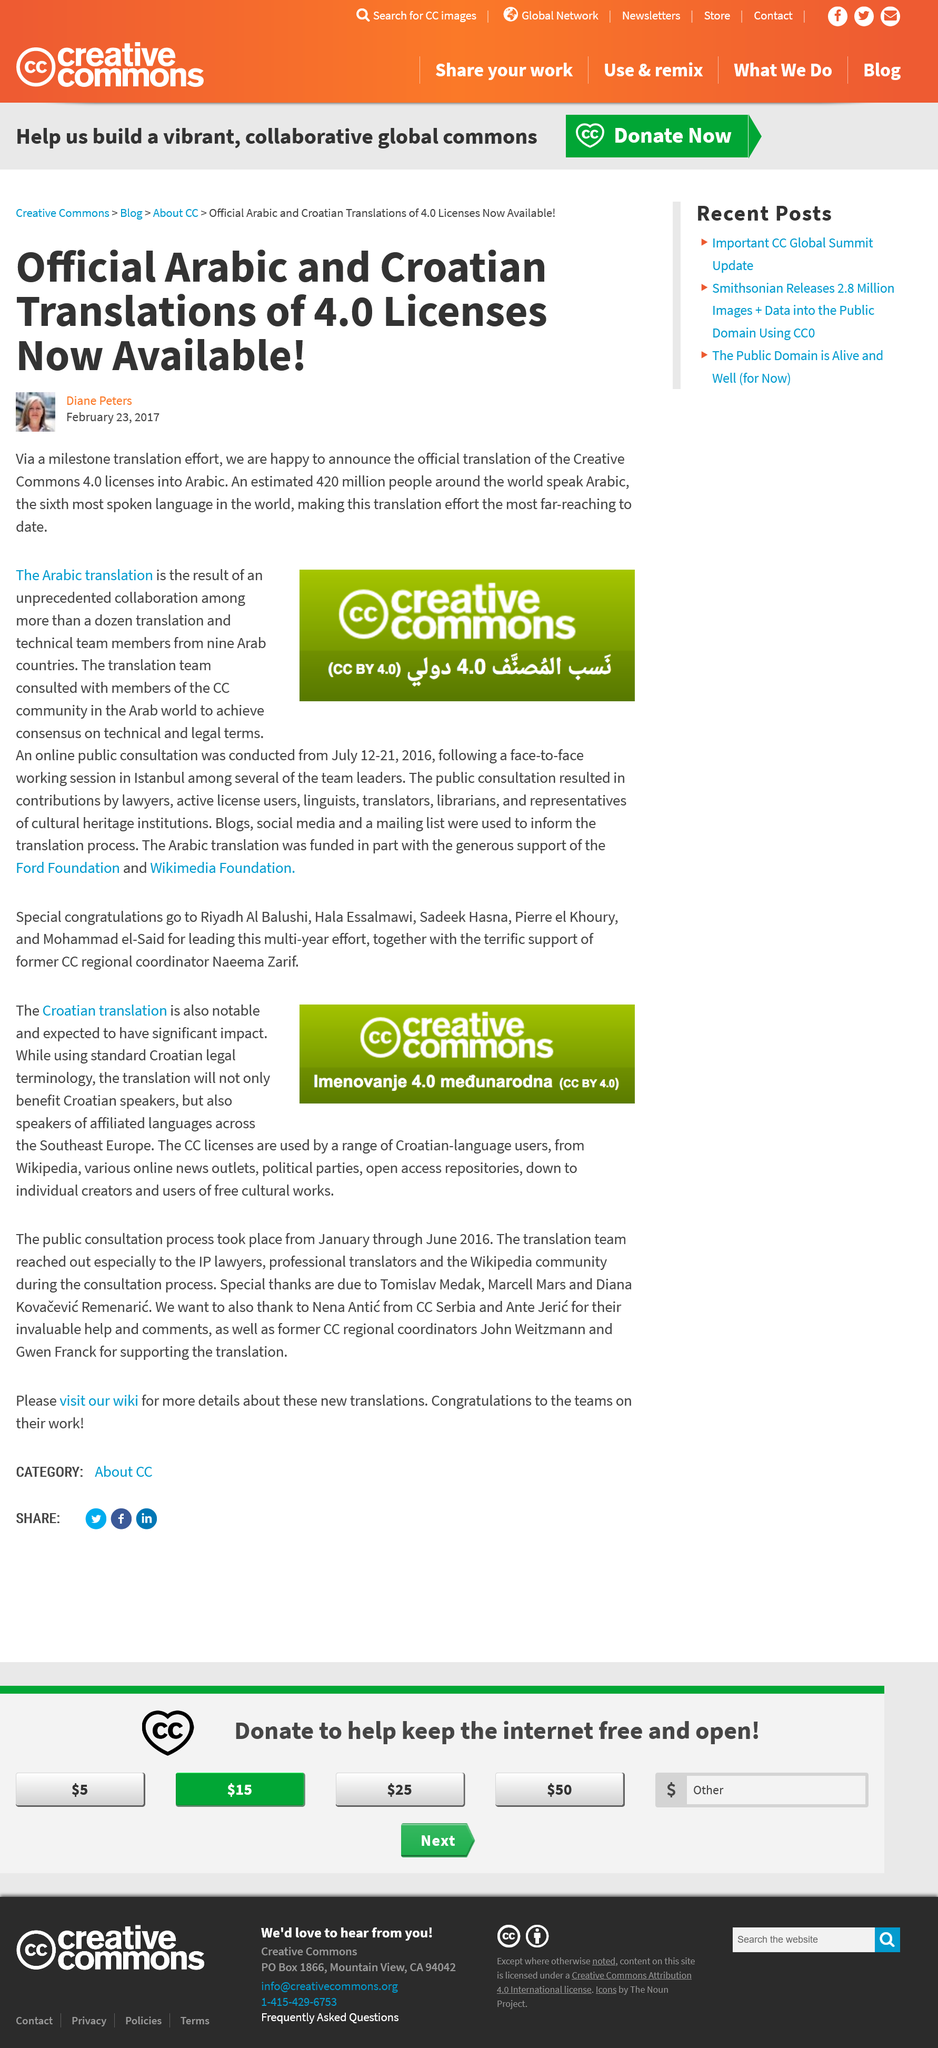Mention a couple of crucial points in this snapshot. Arabic is the sixth most spoken language in the world, with what is the sixth most spoken language in the world being Arabic. The online public consultation took place between July 12 and 21, 2016. The translation team consulted with members of the Creative Commons (CC) community prior to this translation. The CC licenses will be used by a diverse range of Croatian-language users. Approximately 420 million people speak Arabic, making it one of the most widely spoken languages in the world. 